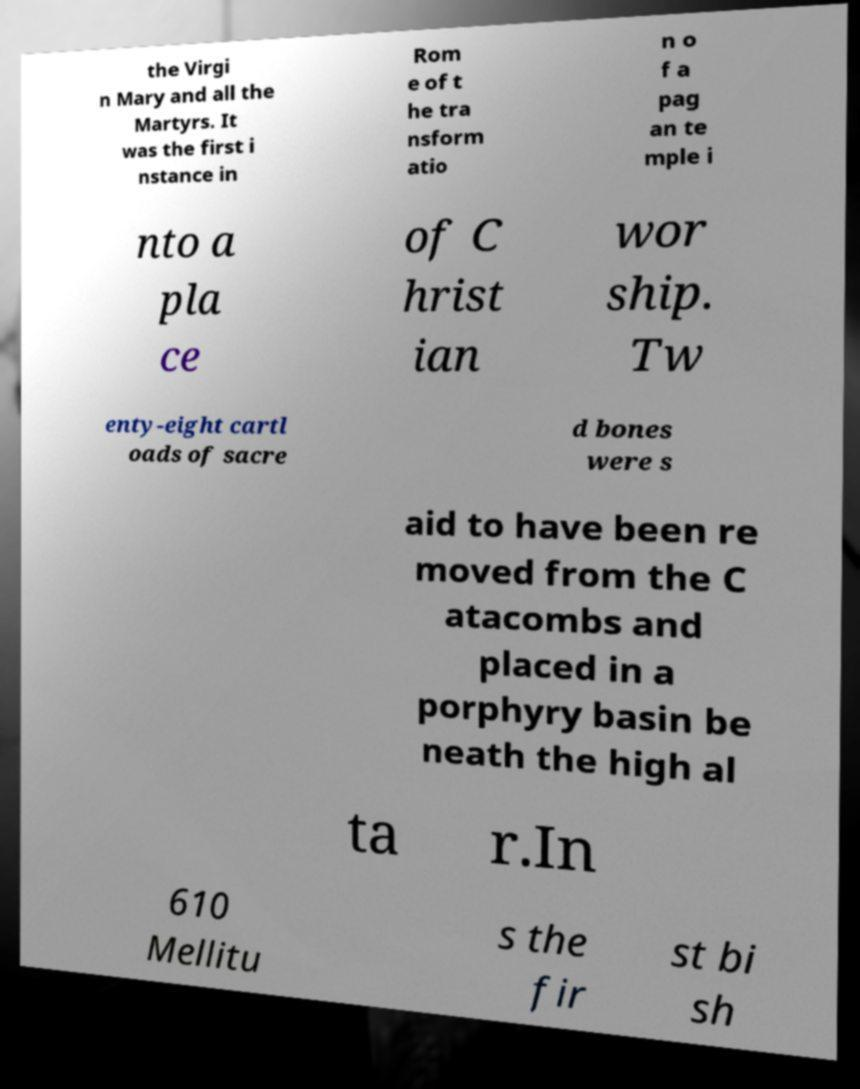I need the written content from this picture converted into text. Can you do that? the Virgi n Mary and all the Martyrs. It was the first i nstance in Rom e of t he tra nsform atio n o f a pag an te mple i nto a pla ce of C hrist ian wor ship. Tw enty-eight cartl oads of sacre d bones were s aid to have been re moved from the C atacombs and placed in a porphyry basin be neath the high al ta r.In 610 Mellitu s the fir st bi sh 